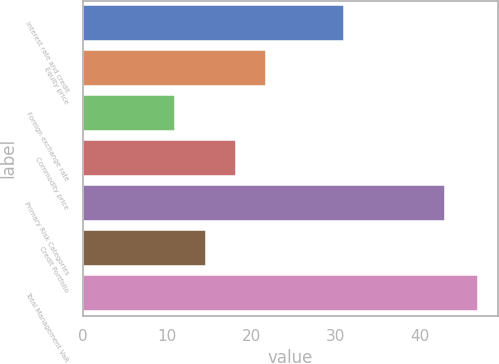<chart> <loc_0><loc_0><loc_500><loc_500><bar_chart><fcel>Interest rate and credit<fcel>Equity price<fcel>Foreign exchange rate<fcel>Commodity price<fcel>Primary Risk Categories<fcel>Credit Portfolio<fcel>Total Management VaR<nl><fcel>31<fcel>21.8<fcel>11<fcel>18.2<fcel>43<fcel>14.6<fcel>47<nl></chart> 